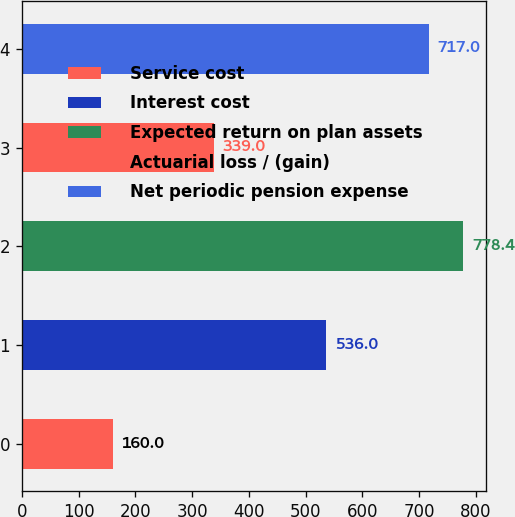Convert chart to OTSL. <chart><loc_0><loc_0><loc_500><loc_500><bar_chart><fcel>Service cost<fcel>Interest cost<fcel>Expected return on plan assets<fcel>Actuarial loss / (gain)<fcel>Net periodic pension expense<nl><fcel>160<fcel>536<fcel>778.4<fcel>339<fcel>717<nl></chart> 